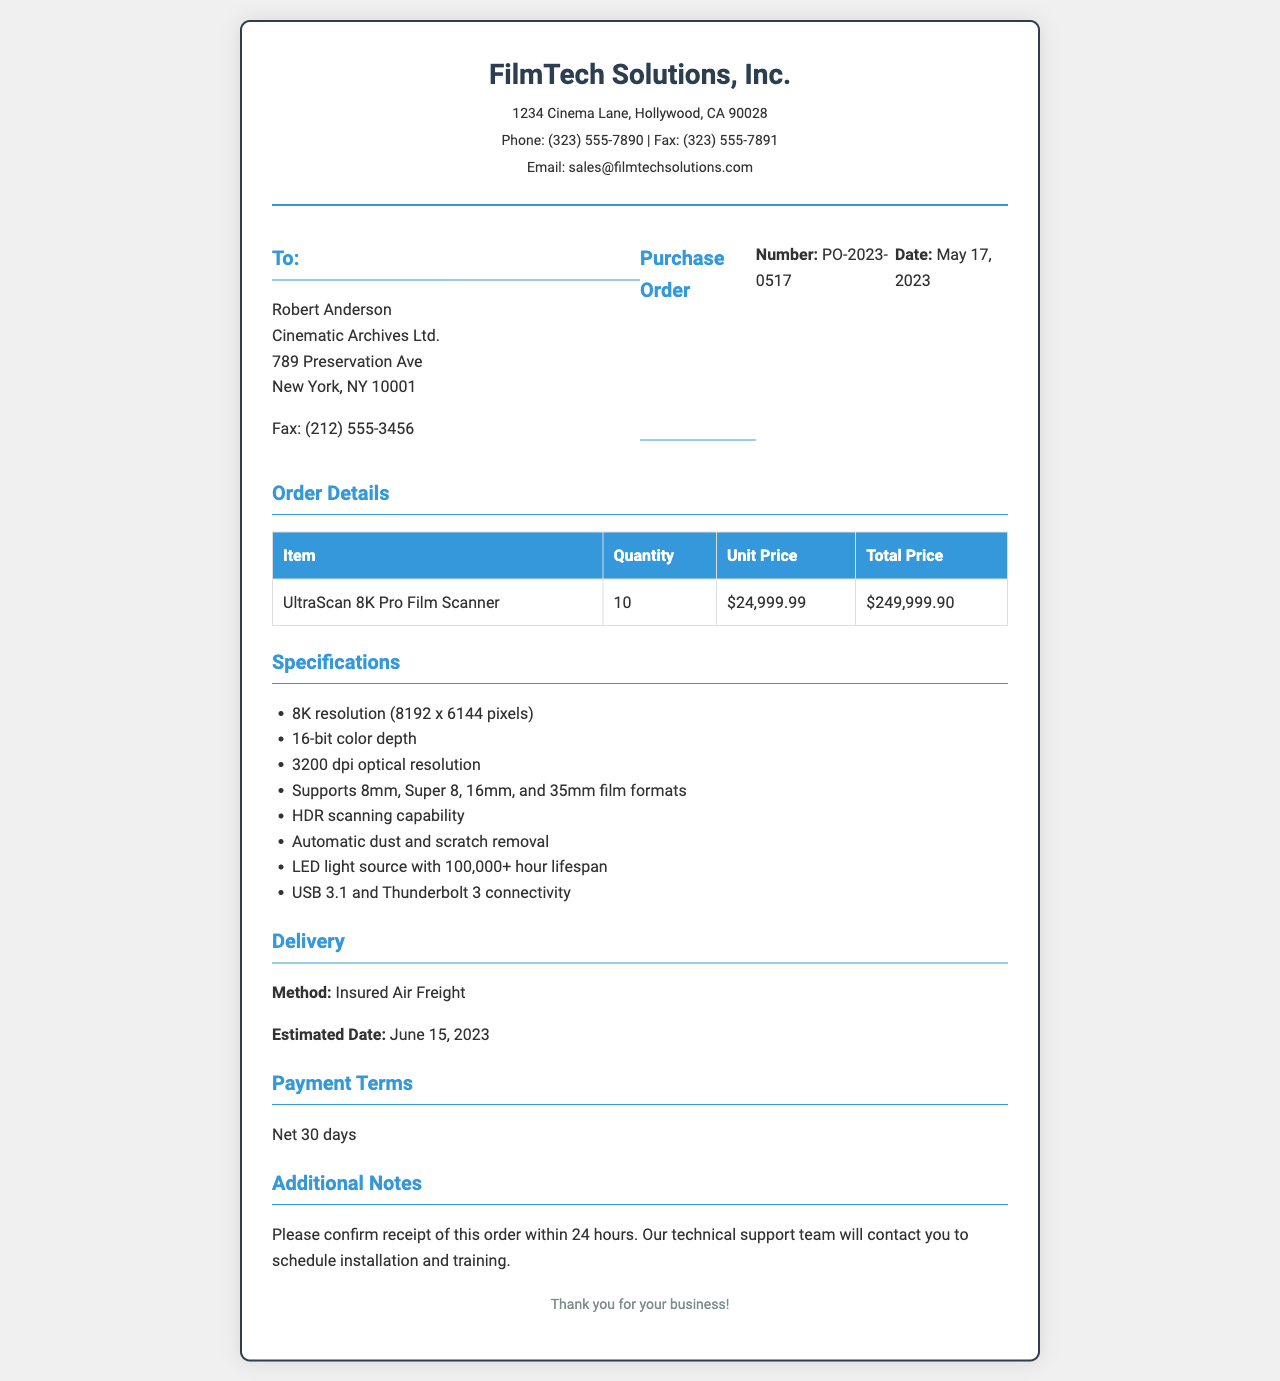What is the name of the company sending the fax? The company's name at the top of the document states "FilmTech Solutions, Inc."
Answer: FilmTech Solutions, Inc Who is the recipient of the fax? The recipient's name is provided under the "To:" section in the fax.
Answer: Robert Anderson What is the purchase order number? The purchase order number is indicated in the "Purchase Order" section of the document.
Answer: PO-2023-0517 How many film scanners are being ordered? The quantity of film scanners is noted in the "Order Details" section of the fax.
Answer: 10 What is the total price for the film scanners? The total price is calculated in the "Order Details" section by multiplying the unit price by quantity.
Answer: $249,999.90 What is the estimated delivery date? The estimated delivery date is mentioned in the "Delivery" section of the document.
Answer: June 15, 2023 What type of film formats does the scanner support? The supported film formats are listed under the "Specifications" section of the fax.
Answer: 8mm, Super 8, 16mm, and 35mm What are the payment terms? The payment terms are indicated in the "Payment Terms" section of the document.
Answer: Net 30 days What is the color depth of the scanner? The color depth specification is listed in the "Specifications" section of the fax.
Answer: 16-bit color depth 